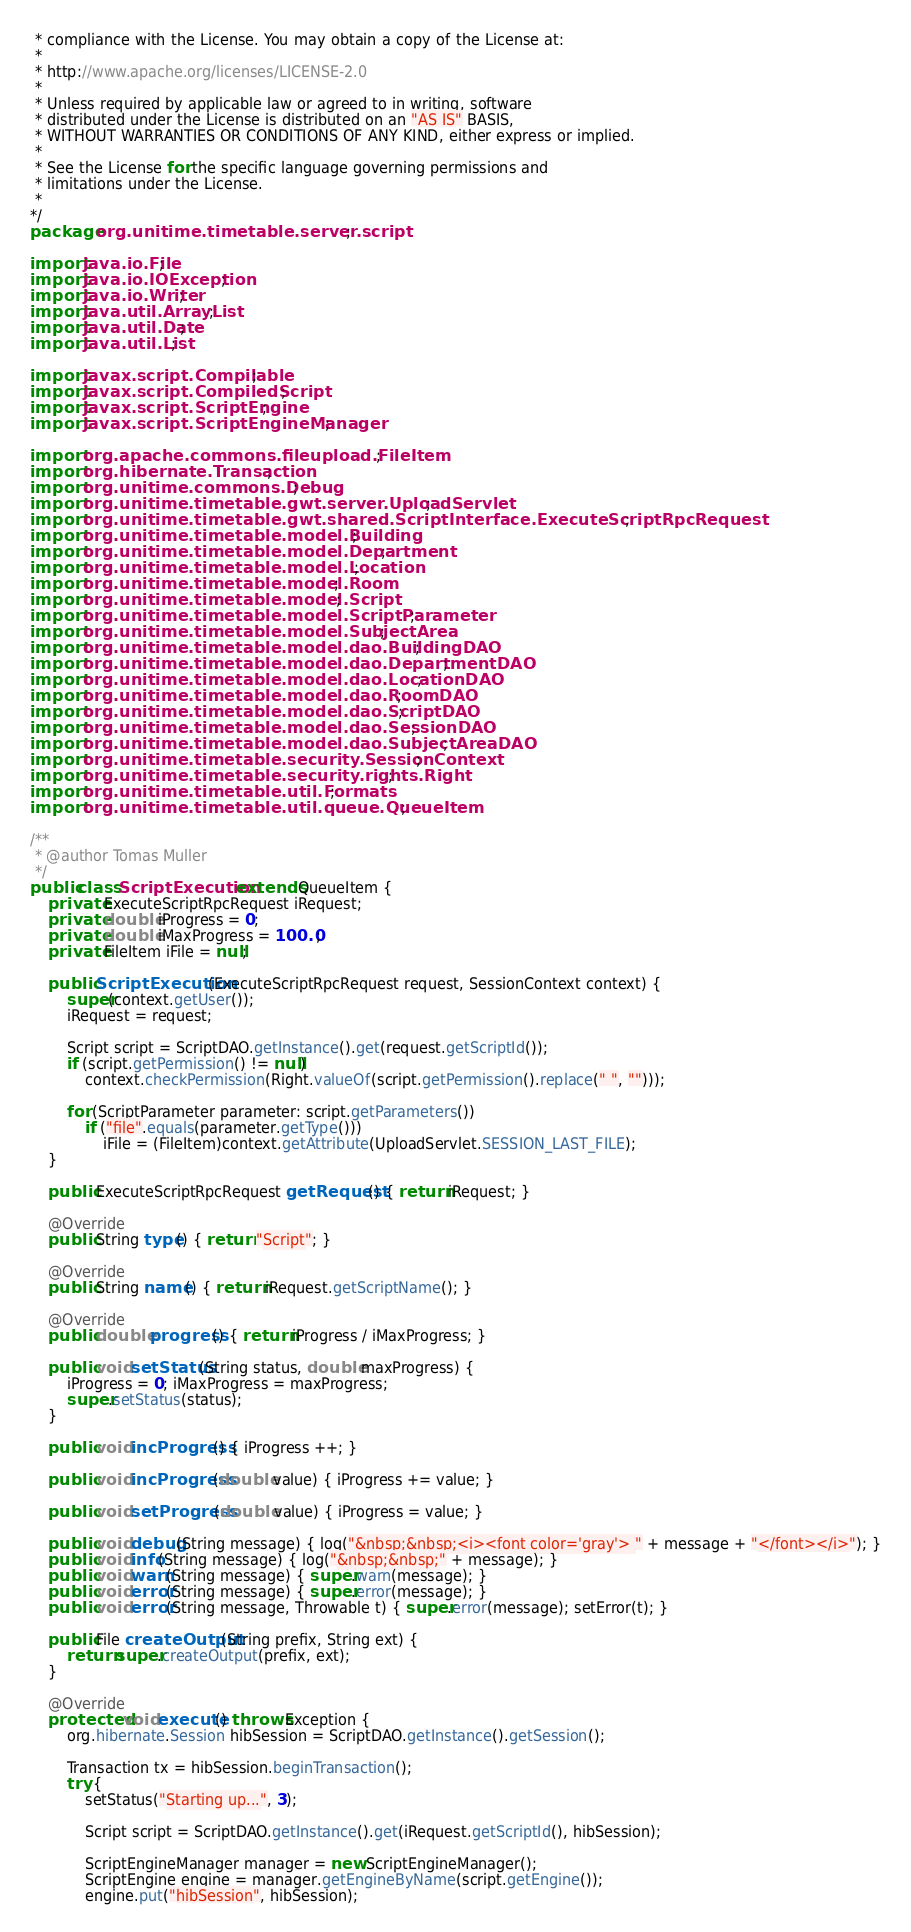Convert code to text. <code><loc_0><loc_0><loc_500><loc_500><_Java_> * compliance with the License. You may obtain a copy of the License at:
 *
 * http://www.apache.org/licenses/LICENSE-2.0
 *
 * Unless required by applicable law or agreed to in writing, software
 * distributed under the License is distributed on an "AS IS" BASIS,
 * WITHOUT WARRANTIES OR CONDITIONS OF ANY KIND, either express or implied.
 *
 * See the License for the specific language governing permissions and
 * limitations under the License.
 * 
*/
package org.unitime.timetable.server.script;

import java.io.File;
import java.io.IOException;
import java.io.Writer;
import java.util.ArrayList;
import java.util.Date;
import java.util.List;

import javax.script.Compilable;
import javax.script.CompiledScript;
import javax.script.ScriptEngine;
import javax.script.ScriptEngineManager;

import org.apache.commons.fileupload.FileItem;
import org.hibernate.Transaction;
import org.unitime.commons.Debug;
import org.unitime.timetable.gwt.server.UploadServlet;
import org.unitime.timetable.gwt.shared.ScriptInterface.ExecuteScriptRpcRequest;
import org.unitime.timetable.model.Building;
import org.unitime.timetable.model.Department;
import org.unitime.timetable.model.Location;
import org.unitime.timetable.model.Room;
import org.unitime.timetable.model.Script;
import org.unitime.timetable.model.ScriptParameter;
import org.unitime.timetable.model.SubjectArea;
import org.unitime.timetable.model.dao.BuildingDAO;
import org.unitime.timetable.model.dao.DepartmentDAO;
import org.unitime.timetable.model.dao.LocationDAO;
import org.unitime.timetable.model.dao.RoomDAO;
import org.unitime.timetable.model.dao.ScriptDAO;
import org.unitime.timetable.model.dao.SessionDAO;
import org.unitime.timetable.model.dao.SubjectAreaDAO;
import org.unitime.timetable.security.SessionContext;
import org.unitime.timetable.security.rights.Right;
import org.unitime.timetable.util.Formats;
import org.unitime.timetable.util.queue.QueueItem;

/**
 * @author Tomas Muller
 */
public class ScriptExecution extends QueueItem {
	private ExecuteScriptRpcRequest iRequest;
	private double iProgress = 0;
	private double iMaxProgress = 100.0;
	private FileItem iFile = null;
	
	public ScriptExecution(ExecuteScriptRpcRequest request, SessionContext context) {
		super(context.getUser());
		iRequest = request;
		
		Script script = ScriptDAO.getInstance().get(request.getScriptId());
		if (script.getPermission() != null)
			context.checkPermission(Right.valueOf(script.getPermission().replace(" ", "")));
		
		for (ScriptParameter parameter: script.getParameters())
			if ("file".equals(parameter.getType()))
				iFile = (FileItem)context.getAttribute(UploadServlet.SESSION_LAST_FILE);
	}
	
	public ExecuteScriptRpcRequest getRequest() { return iRequest; }

	@Override
	public String type() { return "Script"; }

	@Override
	public String name() { return iRequest.getScriptName(); }

	@Override
	public double progress() { return iProgress / iMaxProgress; }
	
	public void setStatus(String status, double maxProgress) {
		iProgress = 0; iMaxProgress = maxProgress;
		super.setStatus(status);
	}
	
	public void incProgress() { iProgress ++; }
	
	public void incProgress(double value) { iProgress += value; }
	
	public void setProgress(double value) { iProgress = value; }
	
	public void debug(String message) { log("&nbsp;&nbsp;<i><font color='gray'> " + message + "</font></i>"); }
	public void info(String message) { log("&nbsp;&nbsp;" + message); }
	public void warn(String message) { super.warn(message); }
	public void error(String message) { super.error(message); }
	public void error(String message, Throwable t) { super.error(message); setError(t); }
	
	public File createOutput(String prefix, String ext) {
		return super.createOutput(prefix, ext);
	}

	@Override
	protected void execute() throws Exception {
		org.hibernate.Session hibSession = ScriptDAO.getInstance().getSession();
		
		Transaction tx = hibSession.beginTransaction();
		try {
			setStatus("Starting up...", 3);

			Script script = ScriptDAO.getInstance().get(iRequest.getScriptId(), hibSession);
			
			ScriptEngineManager manager = new ScriptEngineManager();
			ScriptEngine engine = manager.getEngineByName(script.getEngine());
			engine.put("hibSession", hibSession);</code> 